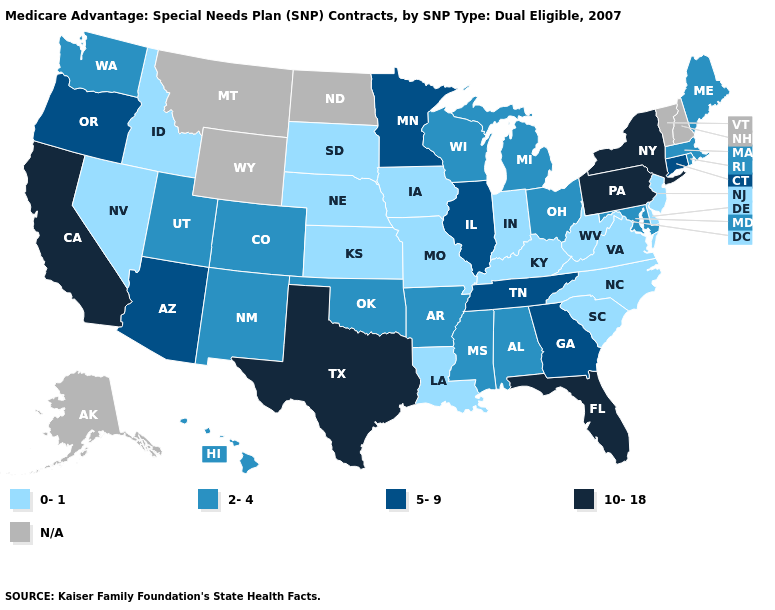What is the highest value in the Northeast ?
Concise answer only. 10-18. Is the legend a continuous bar?
Give a very brief answer. No. What is the value of Alaska?
Concise answer only. N/A. What is the value of South Dakota?
Short answer required. 0-1. Among the states that border Maryland , which have the highest value?
Short answer required. Pennsylvania. What is the value of Ohio?
Write a very short answer. 2-4. What is the value of South Carolina?
Write a very short answer. 0-1. Name the states that have a value in the range 5-9?
Be succinct. Arizona, Connecticut, Georgia, Illinois, Minnesota, Oregon, Tennessee. Name the states that have a value in the range 10-18?
Keep it brief. California, Florida, New York, Pennsylvania, Texas. What is the value of Idaho?
Answer briefly. 0-1. Does the map have missing data?
Answer briefly. Yes. Name the states that have a value in the range 5-9?
Quick response, please. Arizona, Connecticut, Georgia, Illinois, Minnesota, Oregon, Tennessee. What is the lowest value in the Northeast?
Give a very brief answer. 0-1. Does the map have missing data?
Quick response, please. Yes. Does New Mexico have the highest value in the USA?
Concise answer only. No. 